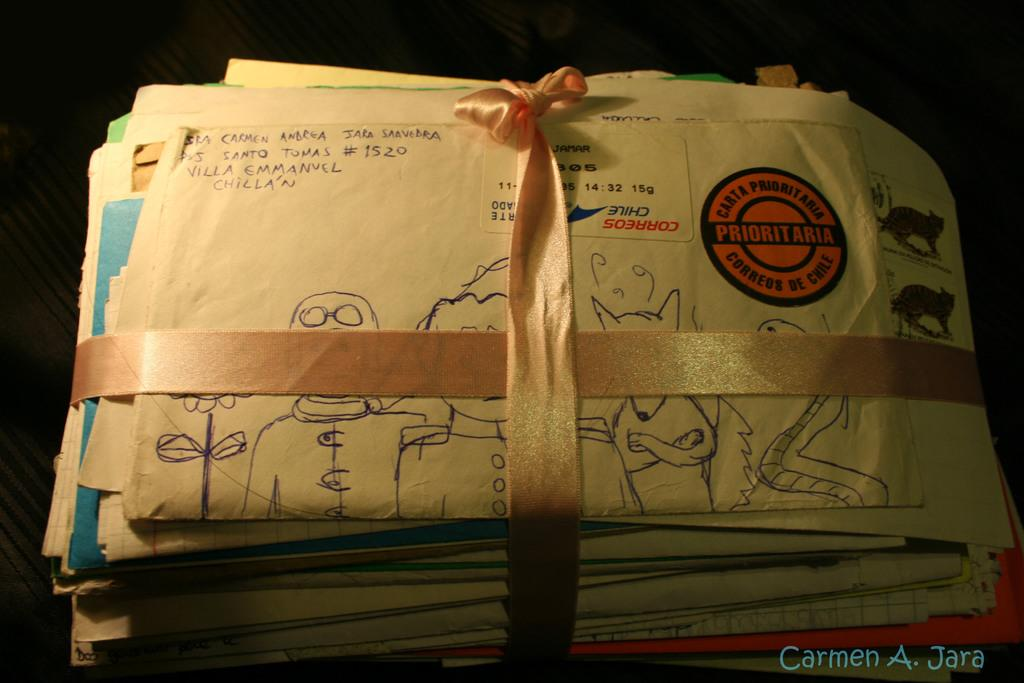<image>
Relay a brief, clear account of the picture shown. Mail addressed to Carmen A. Jara is wrapped in a ribbon and tied with a bow. 